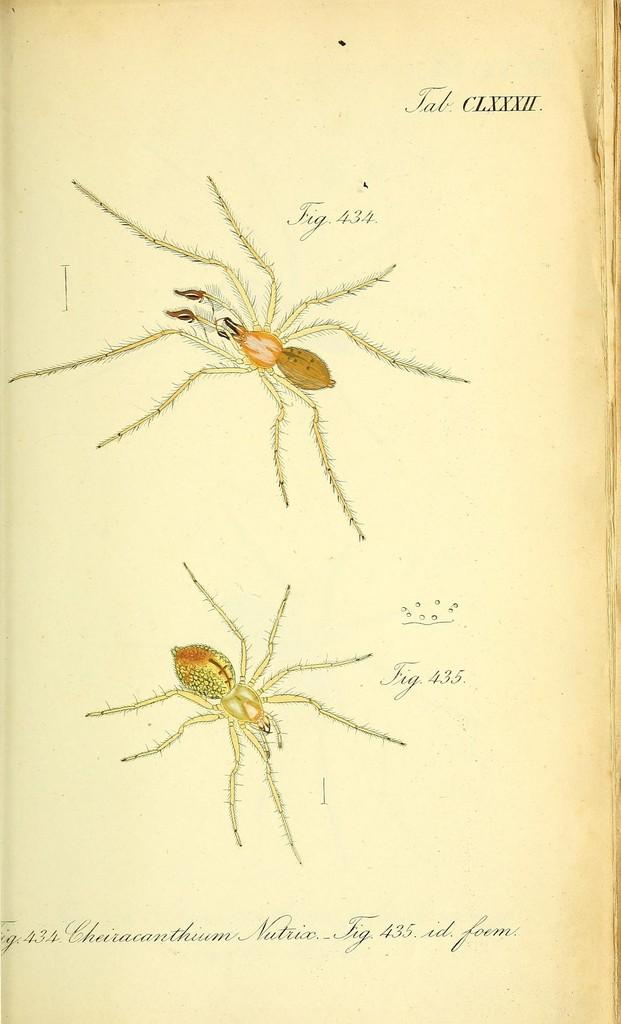What type of image is being described? The image is a poster. What can be seen in the poster? There are depictions of spiders on the poster. Are there any words on the poster? Yes, there is text on the poster. What type of glove is being worn by the spider in the image? There are no gloves or spiders wearing gloves depicted in the image. 